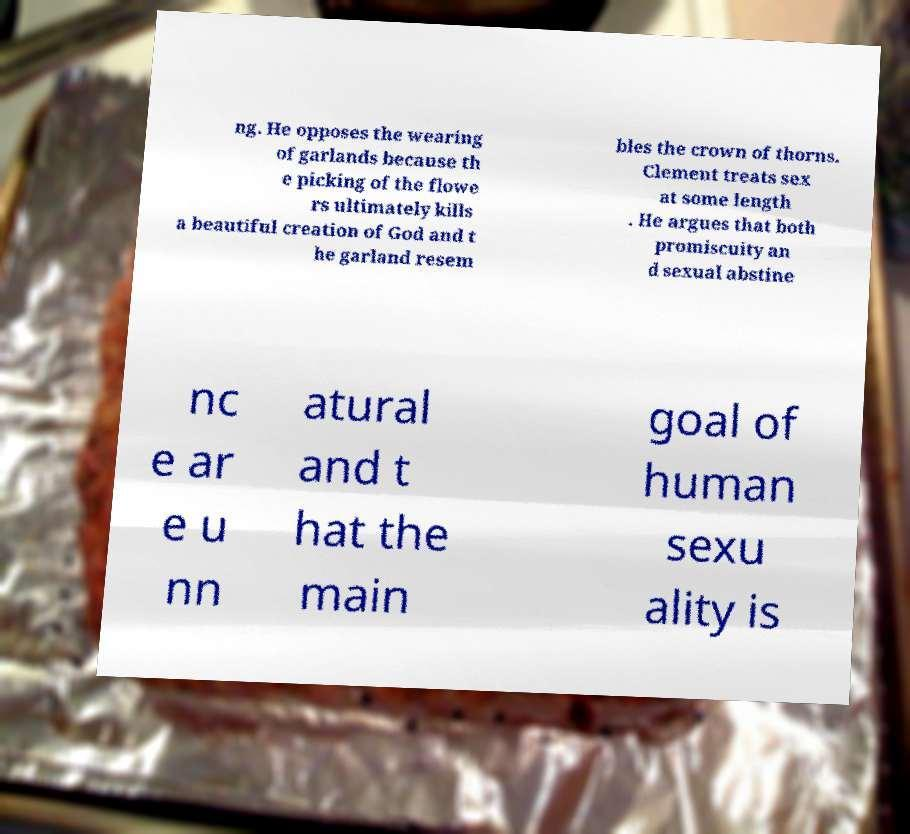There's text embedded in this image that I need extracted. Can you transcribe it verbatim? ng. He opposes the wearing of garlands because th e picking of the flowe rs ultimately kills a beautiful creation of God and t he garland resem bles the crown of thorns. Clement treats sex at some length . He argues that both promiscuity an d sexual abstine nc e ar e u nn atural and t hat the main goal of human sexu ality is 